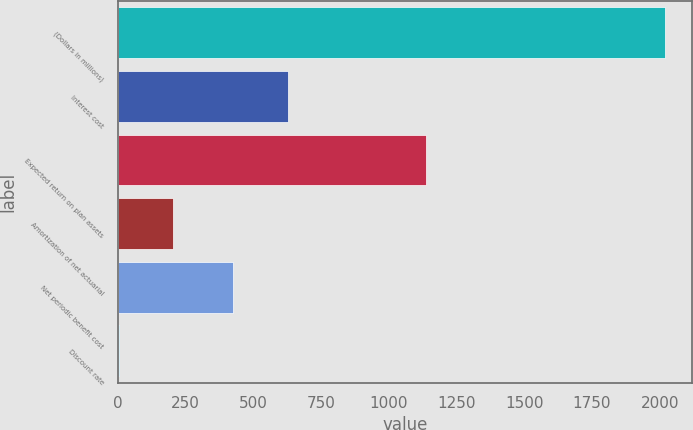Convert chart to OTSL. <chart><loc_0><loc_0><loc_500><loc_500><bar_chart><fcel>(Dollars in millions)<fcel>Interest cost<fcel>Expected return on plan assets<fcel>Amortization of net actuarial<fcel>Net periodic benefit cost<fcel>Discount rate<nl><fcel>2018<fcel>627.43<fcel>1136<fcel>205.11<fcel>426<fcel>3.68<nl></chart> 